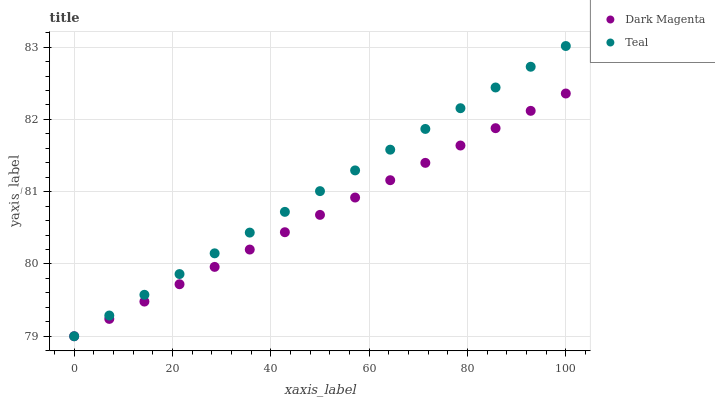Does Dark Magenta have the minimum area under the curve?
Answer yes or no. Yes. Does Teal have the maximum area under the curve?
Answer yes or no. Yes. Does Teal have the minimum area under the curve?
Answer yes or no. No. Is Dark Magenta the smoothest?
Answer yes or no. Yes. Is Teal the roughest?
Answer yes or no. Yes. Is Teal the smoothest?
Answer yes or no. No. Does Dark Magenta have the lowest value?
Answer yes or no. Yes. Does Teal have the highest value?
Answer yes or no. Yes. Does Teal intersect Dark Magenta?
Answer yes or no. Yes. Is Teal less than Dark Magenta?
Answer yes or no. No. Is Teal greater than Dark Magenta?
Answer yes or no. No. 